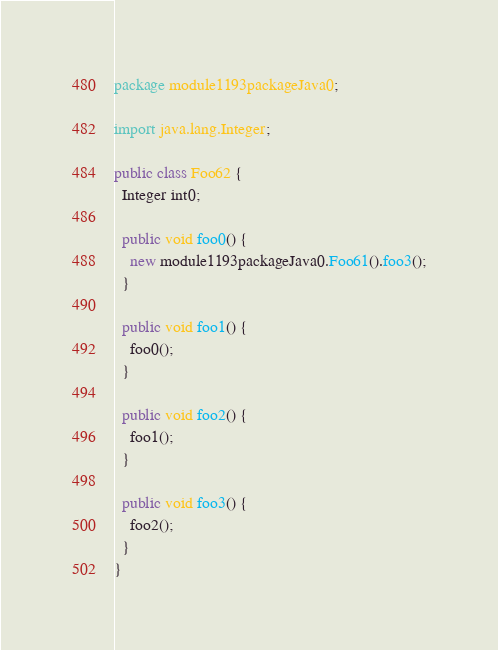Convert code to text. <code><loc_0><loc_0><loc_500><loc_500><_Java_>package module1193packageJava0;

import java.lang.Integer;

public class Foo62 {
  Integer int0;

  public void foo0() {
    new module1193packageJava0.Foo61().foo3();
  }

  public void foo1() {
    foo0();
  }

  public void foo2() {
    foo1();
  }

  public void foo3() {
    foo2();
  }
}
</code> 